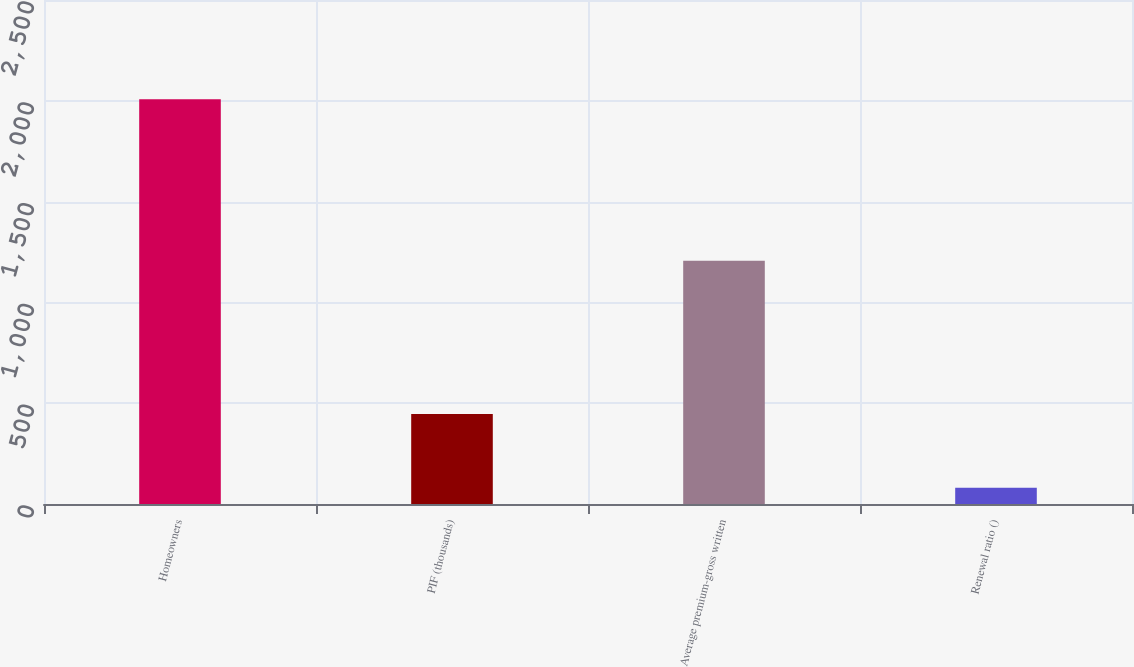Convert chart. <chart><loc_0><loc_0><loc_500><loc_500><bar_chart><fcel>Homeowners<fcel>PIF (thousands)<fcel>Average premium-gross written<fcel>Renewal ratio ()<nl><fcel>2008<fcel>446<fcel>1206<fcel>80.6<nl></chart> 